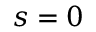Convert formula to latex. <formula><loc_0><loc_0><loc_500><loc_500>s = 0</formula> 